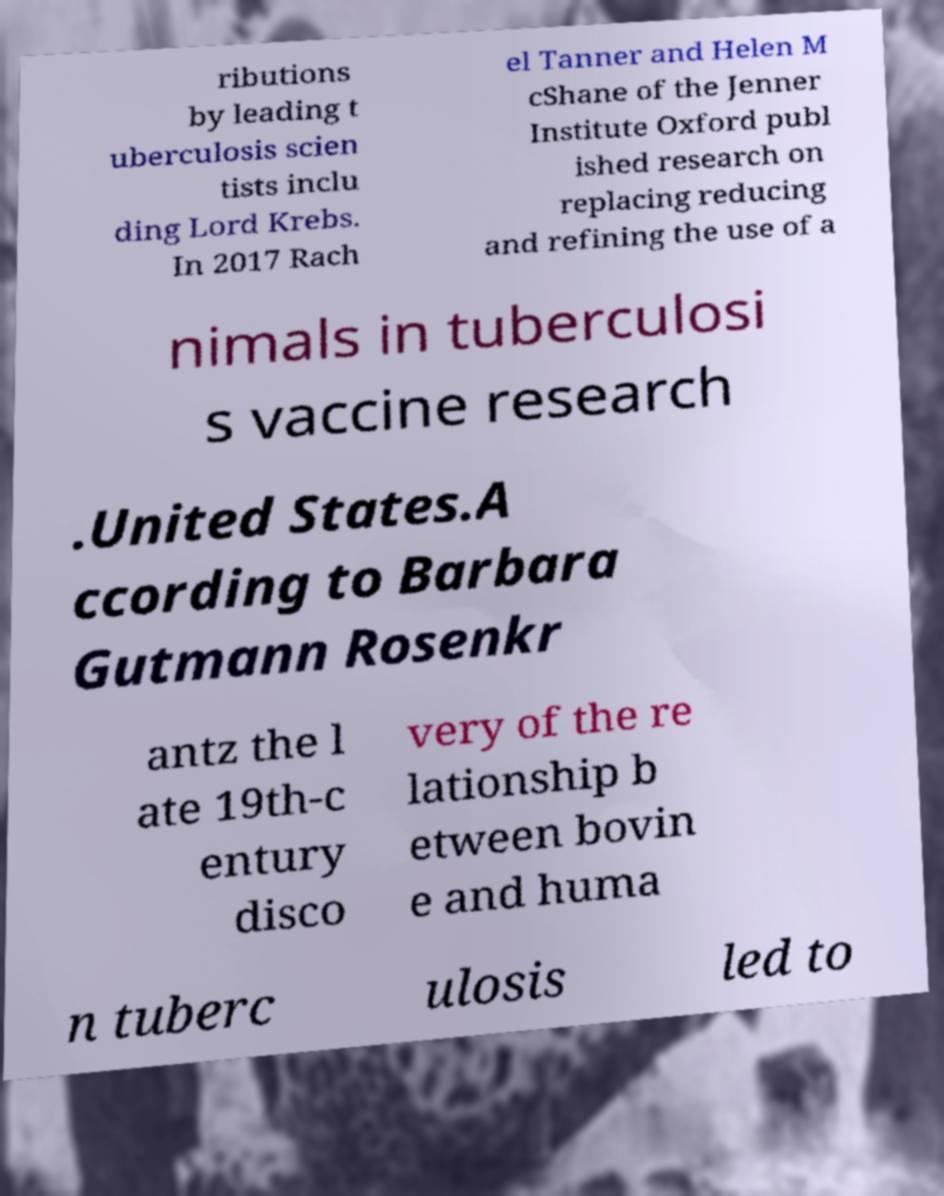For documentation purposes, I need the text within this image transcribed. Could you provide that? ributions by leading t uberculosis scien tists inclu ding Lord Krebs. In 2017 Rach el Tanner and Helen M cShane of the Jenner Institute Oxford publ ished research on replacing reducing and refining the use of a nimals in tuberculosi s vaccine research .United States.A ccording to Barbara Gutmann Rosenkr antz the l ate 19th-c entury disco very of the re lationship b etween bovin e and huma n tuberc ulosis led to 